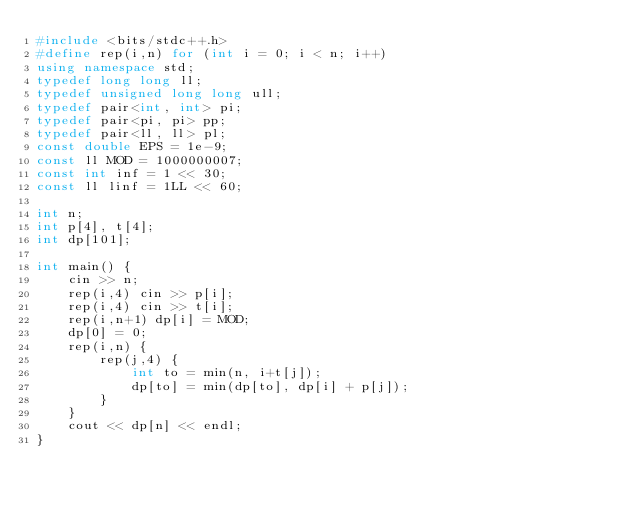Convert code to text. <code><loc_0><loc_0><loc_500><loc_500><_C++_>#include <bits/stdc++.h>
#define rep(i,n) for (int i = 0; i < n; i++)
using namespace std;
typedef long long ll;
typedef unsigned long long ull;
typedef pair<int, int> pi;
typedef pair<pi, pi> pp;
typedef pair<ll, ll> pl;
const double EPS = 1e-9;
const ll MOD = 1000000007;
const int inf = 1 << 30;
const ll linf = 1LL << 60;

int n;
int p[4], t[4];
int dp[101];

int main() {
    cin >> n;
    rep(i,4) cin >> p[i];
    rep(i,4) cin >> t[i];
    rep(i,n+1) dp[i] = MOD;
    dp[0] = 0;
    rep(i,n) {
        rep(j,4) {
            int to = min(n, i+t[j]);
            dp[to] = min(dp[to], dp[i] + p[j]);
        }
    }
    cout << dp[n] << endl;
}

</code> 